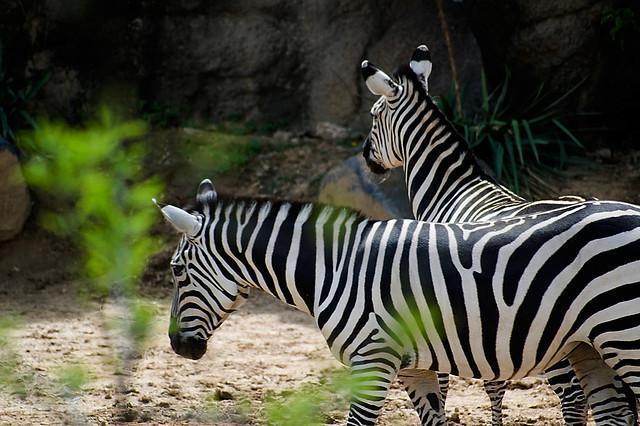How many zoo animals are there?
Give a very brief answer. 2. How many zebras are visible?
Give a very brief answer. 2. How many teddy bears can be seen?
Give a very brief answer. 0. 